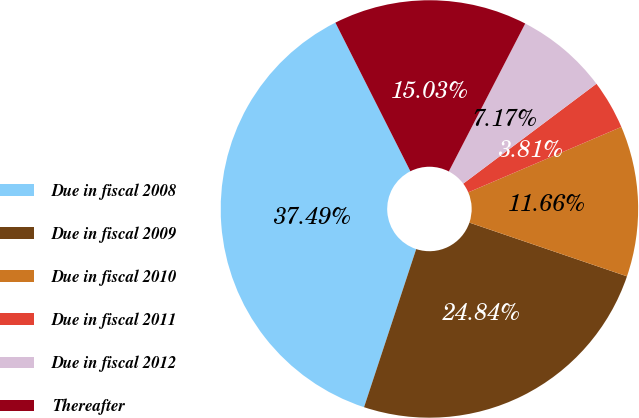Convert chart to OTSL. <chart><loc_0><loc_0><loc_500><loc_500><pie_chart><fcel>Due in fiscal 2008<fcel>Due in fiscal 2009<fcel>Due in fiscal 2010<fcel>Due in fiscal 2011<fcel>Due in fiscal 2012<fcel>Thereafter<nl><fcel>37.49%<fcel>24.84%<fcel>11.66%<fcel>3.81%<fcel>7.17%<fcel>15.03%<nl></chart> 